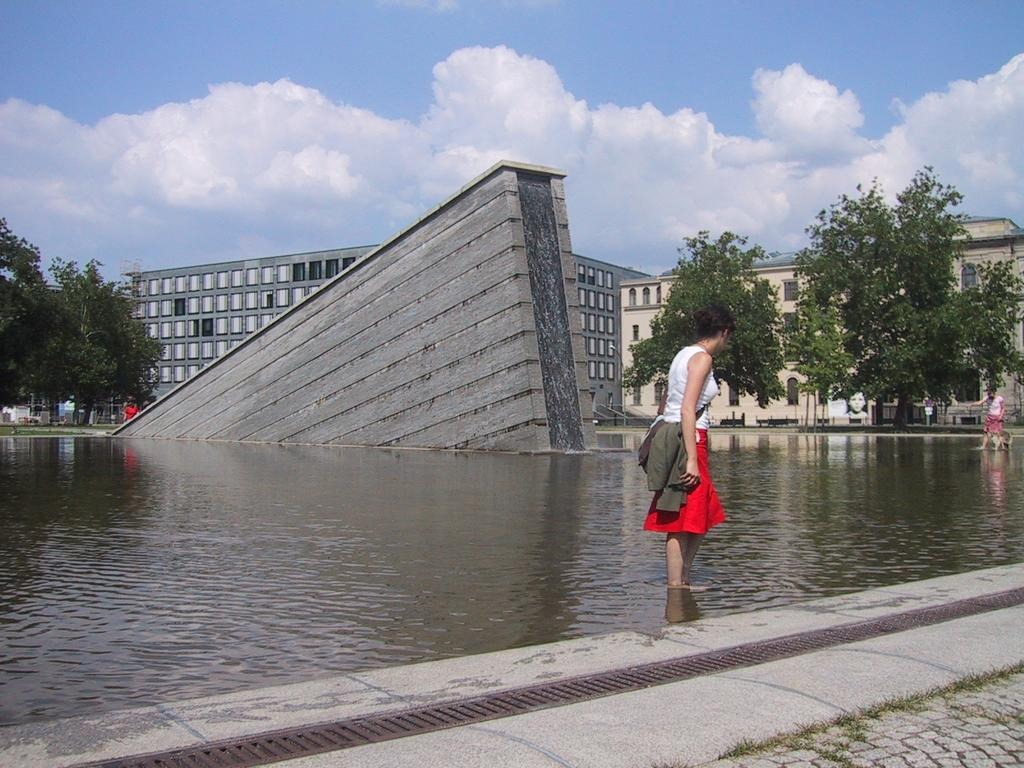What is the person in the image doing? The person is standing in the water. What can be seen in the background of the image? There is a group of people, a dog, a waterfall, buildings, benches, trees, and the sky visible in the background. How many people are in the background? There is a group of people in the background, but the exact number cannot be determined from the image. What type of spot is the person standing on in the image? There is no mention of a spot in the image; the person is standing in the water. How many masses can be seen in the image? There is no mention of masses in the image; the focus is on the person standing in the water and the various elements in the background. 